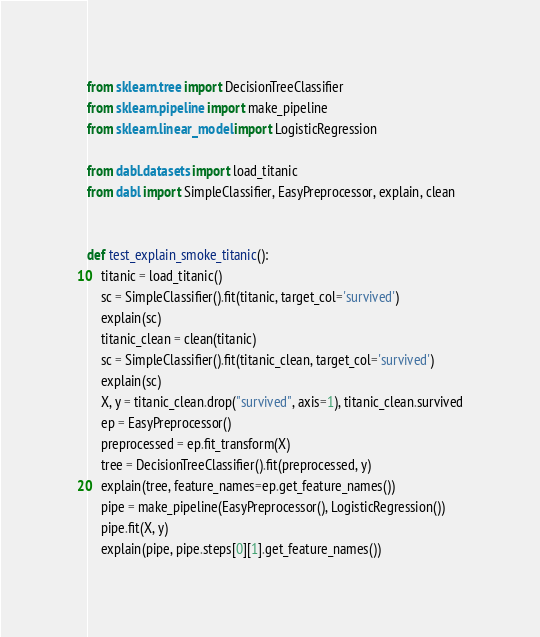<code> <loc_0><loc_0><loc_500><loc_500><_Python_>from sklearn.tree import DecisionTreeClassifier
from sklearn.pipeline import make_pipeline
from sklearn.linear_model import LogisticRegression

from dabl.datasets import load_titanic
from dabl import SimpleClassifier, EasyPreprocessor, explain, clean


def test_explain_smoke_titanic():
    titanic = load_titanic()
    sc = SimpleClassifier().fit(titanic, target_col='survived')
    explain(sc)
    titanic_clean = clean(titanic)
    sc = SimpleClassifier().fit(titanic_clean, target_col='survived')
    explain(sc)
    X, y = titanic_clean.drop("survived", axis=1), titanic_clean.survived
    ep = EasyPreprocessor()
    preprocessed = ep.fit_transform(X)
    tree = DecisionTreeClassifier().fit(preprocessed, y)
    explain(tree, feature_names=ep.get_feature_names())
    pipe = make_pipeline(EasyPreprocessor(), LogisticRegression())
    pipe.fit(X, y)
    explain(pipe, pipe.steps[0][1].get_feature_names())
</code> 